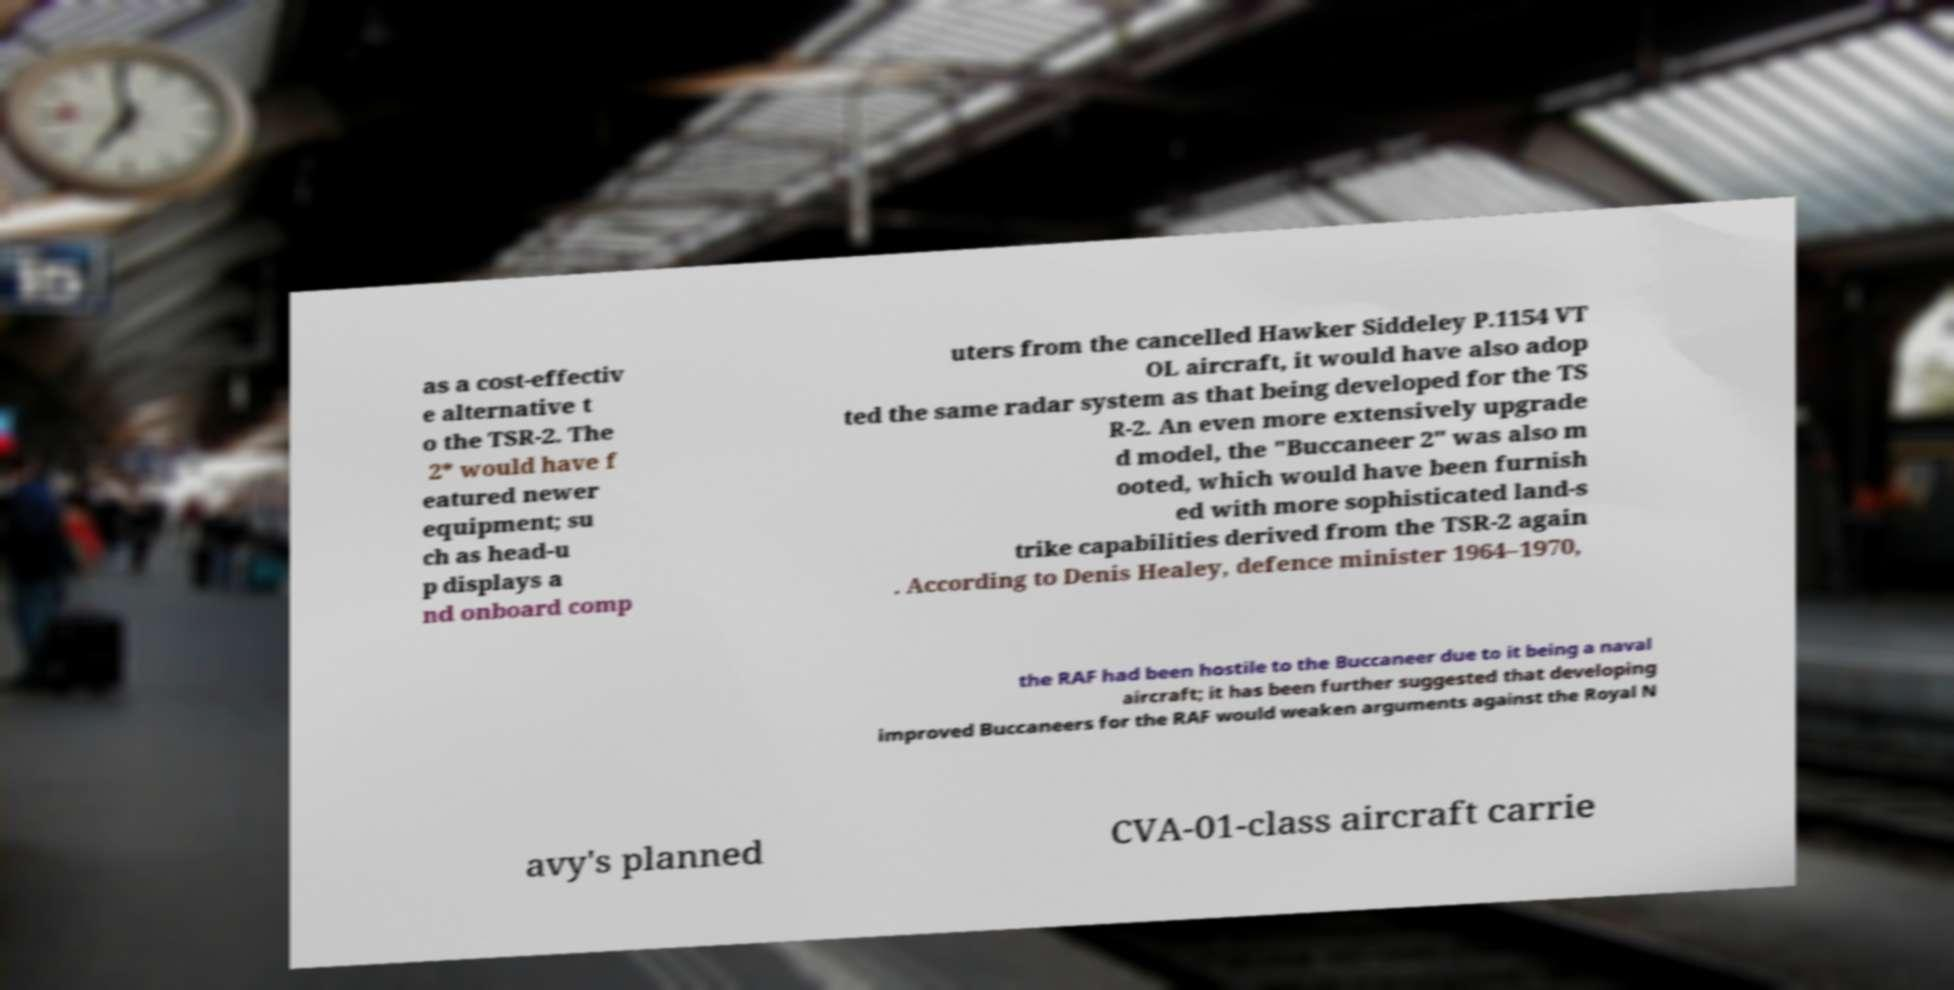Please identify and transcribe the text found in this image. as a cost-effectiv e alternative t o the TSR-2. The 2* would have f eatured newer equipment; su ch as head-u p displays a nd onboard comp uters from the cancelled Hawker Siddeley P.1154 VT OL aircraft, it would have also adop ted the same radar system as that being developed for the TS R-2. An even more extensively upgrade d model, the "Buccaneer 2" was also m ooted, which would have been furnish ed with more sophisticated land-s trike capabilities derived from the TSR-2 again . According to Denis Healey, defence minister 1964–1970, the RAF had been hostile to the Buccaneer due to it being a naval aircraft; it has been further suggested that developing improved Buccaneers for the RAF would weaken arguments against the Royal N avy's planned CVA-01-class aircraft carrie 